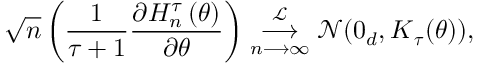Convert formula to latex. <formula><loc_0><loc_0><loc_500><loc_500>\sqrt { n } \left ( \frac { 1 } { \tau + 1 } \frac { \partial H _ { n } ^ { \tau } \left ( \theta \right ) } { \partial \theta } \right ) \underset { n \longrightarrow \infty } { \overset { \mathcal { L } } { \longrightarrow } } \mathcal { N } ( 0 _ { d } , K _ { \tau } ( \theta ) ) ,</formula> 